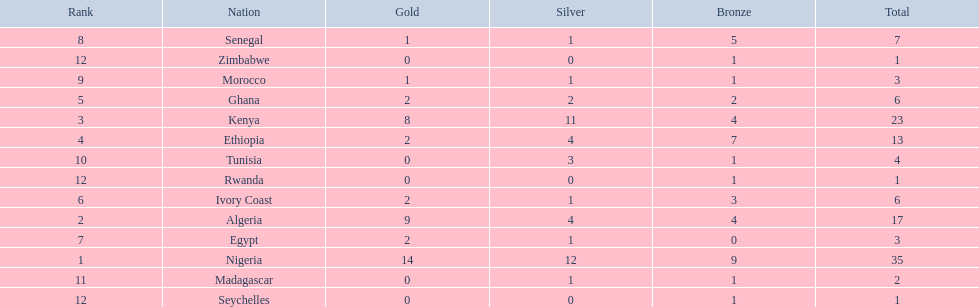Which nations competed in the 1989 african championships in athletics? Nigeria, Algeria, Kenya, Ethiopia, Ghana, Ivory Coast, Egypt, Senegal, Morocco, Tunisia, Madagascar, Rwanda, Zimbabwe, Seychelles. Of these nations, which earned 0 bronze medals? Egypt. I'm looking to parse the entire table for insights. Could you assist me with that? {'header': ['Rank', 'Nation', 'Gold', 'Silver', 'Bronze', 'Total'], 'rows': [['8', 'Senegal', '1', '1', '5', '7'], ['12', 'Zimbabwe', '0', '0', '1', '1'], ['9', 'Morocco', '1', '1', '1', '3'], ['5', 'Ghana', '2', '2', '2', '6'], ['3', 'Kenya', '8', '11', '4', '23'], ['4', 'Ethiopia', '2', '4', '7', '13'], ['10', 'Tunisia', '0', '3', '1', '4'], ['12', 'Rwanda', '0', '0', '1', '1'], ['6', 'Ivory Coast', '2', '1', '3', '6'], ['2', 'Algeria', '9', '4', '4', '17'], ['7', 'Egypt', '2', '1', '0', '3'], ['1', 'Nigeria', '14', '12', '9', '35'], ['11', 'Madagascar', '0', '1', '1', '2'], ['12', 'Seychelles', '0', '0', '1', '1']]} 